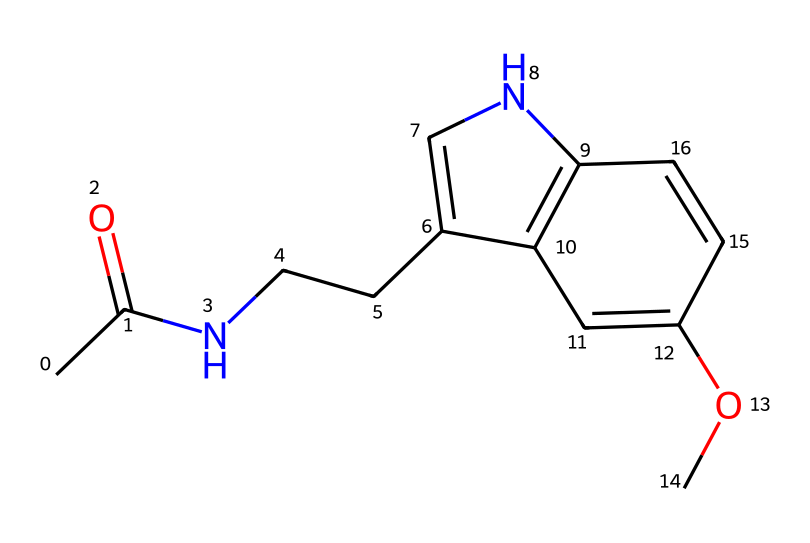What is the molecular formula of melatonin? The molecular formula can be determined by counting the number of each type of atom present in the SMILES representation. The breakdown reveals 13 Carbon atoms (C), 17 Hydrogen atoms (H), 2 Nitrogen atoms (N), and 2 Oxygen atoms (O). Therefore, the molecular formula is C13H17N2O2.
Answer: C13H17N2O2 How many rings are present in the structure of melatonin? Observing the structure, there are two distinct ring systems. One is a pyrrole ring involving one nitrogen atom, and the other is part of an indole structure. Therefore, the total count of rings present is two.
Answer: 2 What type of functional groups are present in melatonin? Analyzing the structure, the most prominent functional groups noted include an acetyl group (–C(=O)CH3) and a methoxy group (–OCH3), indicating that melatonin contains both an amide functional group and an ether functional group.
Answer: amide and ether What property of melatonin allows it to regulate sleep? The chemical structure indicates the presence of the indole ring, along with the nitrogen atoms, which allows melatonin to bind to specific receptors in the brain, thus facilitating its role in sleep regulation.
Answer: indole ring How many carbon atoms are directly bonded to the nitrogen atom in the melatonin structure? Analyzing the structure, we see that there are two carbon atoms that are adjacent to the nitrogen atom in the chain leading to the pyrrole ring, called a side-chain. Thus, the number of direct carbon atoms bonded to nitrogen is two.
Answer: 2 